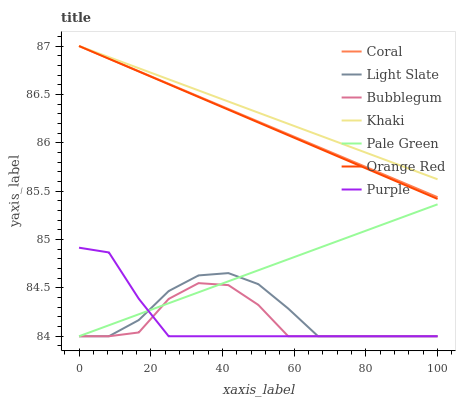Does Purple have the minimum area under the curve?
Answer yes or no. Yes. Does Khaki have the maximum area under the curve?
Answer yes or no. Yes. Does Light Slate have the minimum area under the curve?
Answer yes or no. No. Does Light Slate have the maximum area under the curve?
Answer yes or no. No. Is Pale Green the smoothest?
Answer yes or no. Yes. Is Bubblegum the roughest?
Answer yes or no. Yes. Is Light Slate the smoothest?
Answer yes or no. No. Is Light Slate the roughest?
Answer yes or no. No. Does Light Slate have the lowest value?
Answer yes or no. Yes. Does Coral have the lowest value?
Answer yes or no. No. Does Orange Red have the highest value?
Answer yes or no. Yes. Does Light Slate have the highest value?
Answer yes or no. No. Is Purple less than Coral?
Answer yes or no. Yes. Is Khaki greater than Purple?
Answer yes or no. Yes. Does Coral intersect Khaki?
Answer yes or no. Yes. Is Coral less than Khaki?
Answer yes or no. No. Is Coral greater than Khaki?
Answer yes or no. No. Does Purple intersect Coral?
Answer yes or no. No. 